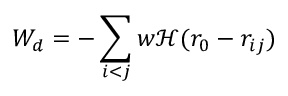<formula> <loc_0><loc_0><loc_500><loc_500>W _ { d } = - \sum _ { i < j } w \mathcal { H } ( r _ { 0 } - r _ { i j } )</formula> 